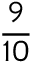Convert formula to latex. <formula><loc_0><loc_0><loc_500><loc_500>\frac { 9 } { 1 0 }</formula> 